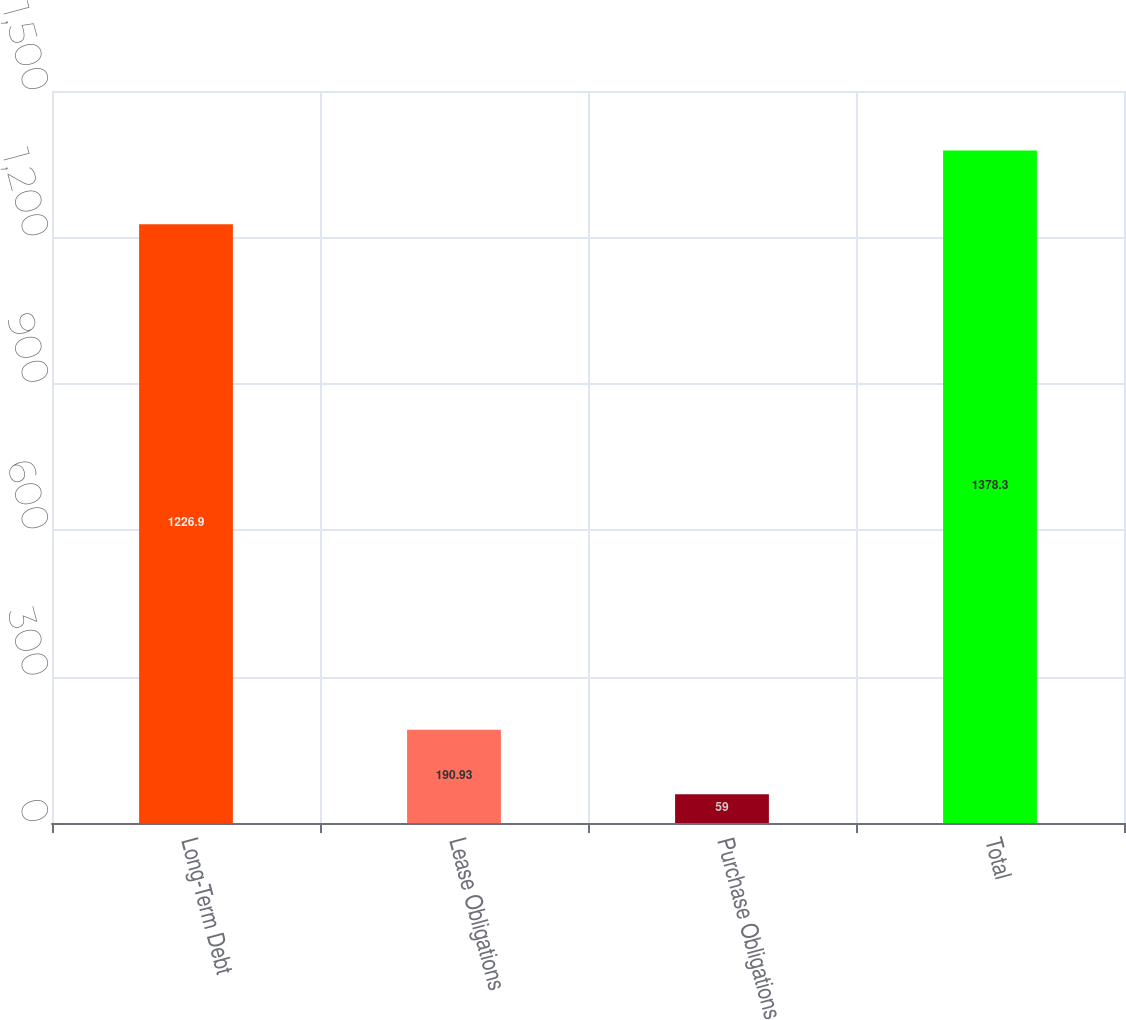<chart> <loc_0><loc_0><loc_500><loc_500><bar_chart><fcel>Long-Term Debt<fcel>Lease Obligations<fcel>Purchase Obligations<fcel>Total<nl><fcel>1226.9<fcel>190.93<fcel>59<fcel>1378.3<nl></chart> 